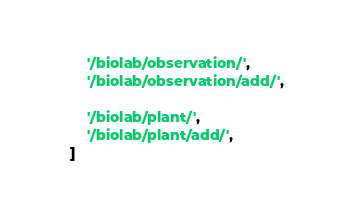Convert code to text. <code><loc_0><loc_0><loc_500><loc_500><_Python_>
        '/biolab/observation/',
        '/biolab/observation/add/',

        '/biolab/plant/',
        '/biolab/plant/add/',
    ]
</code> 